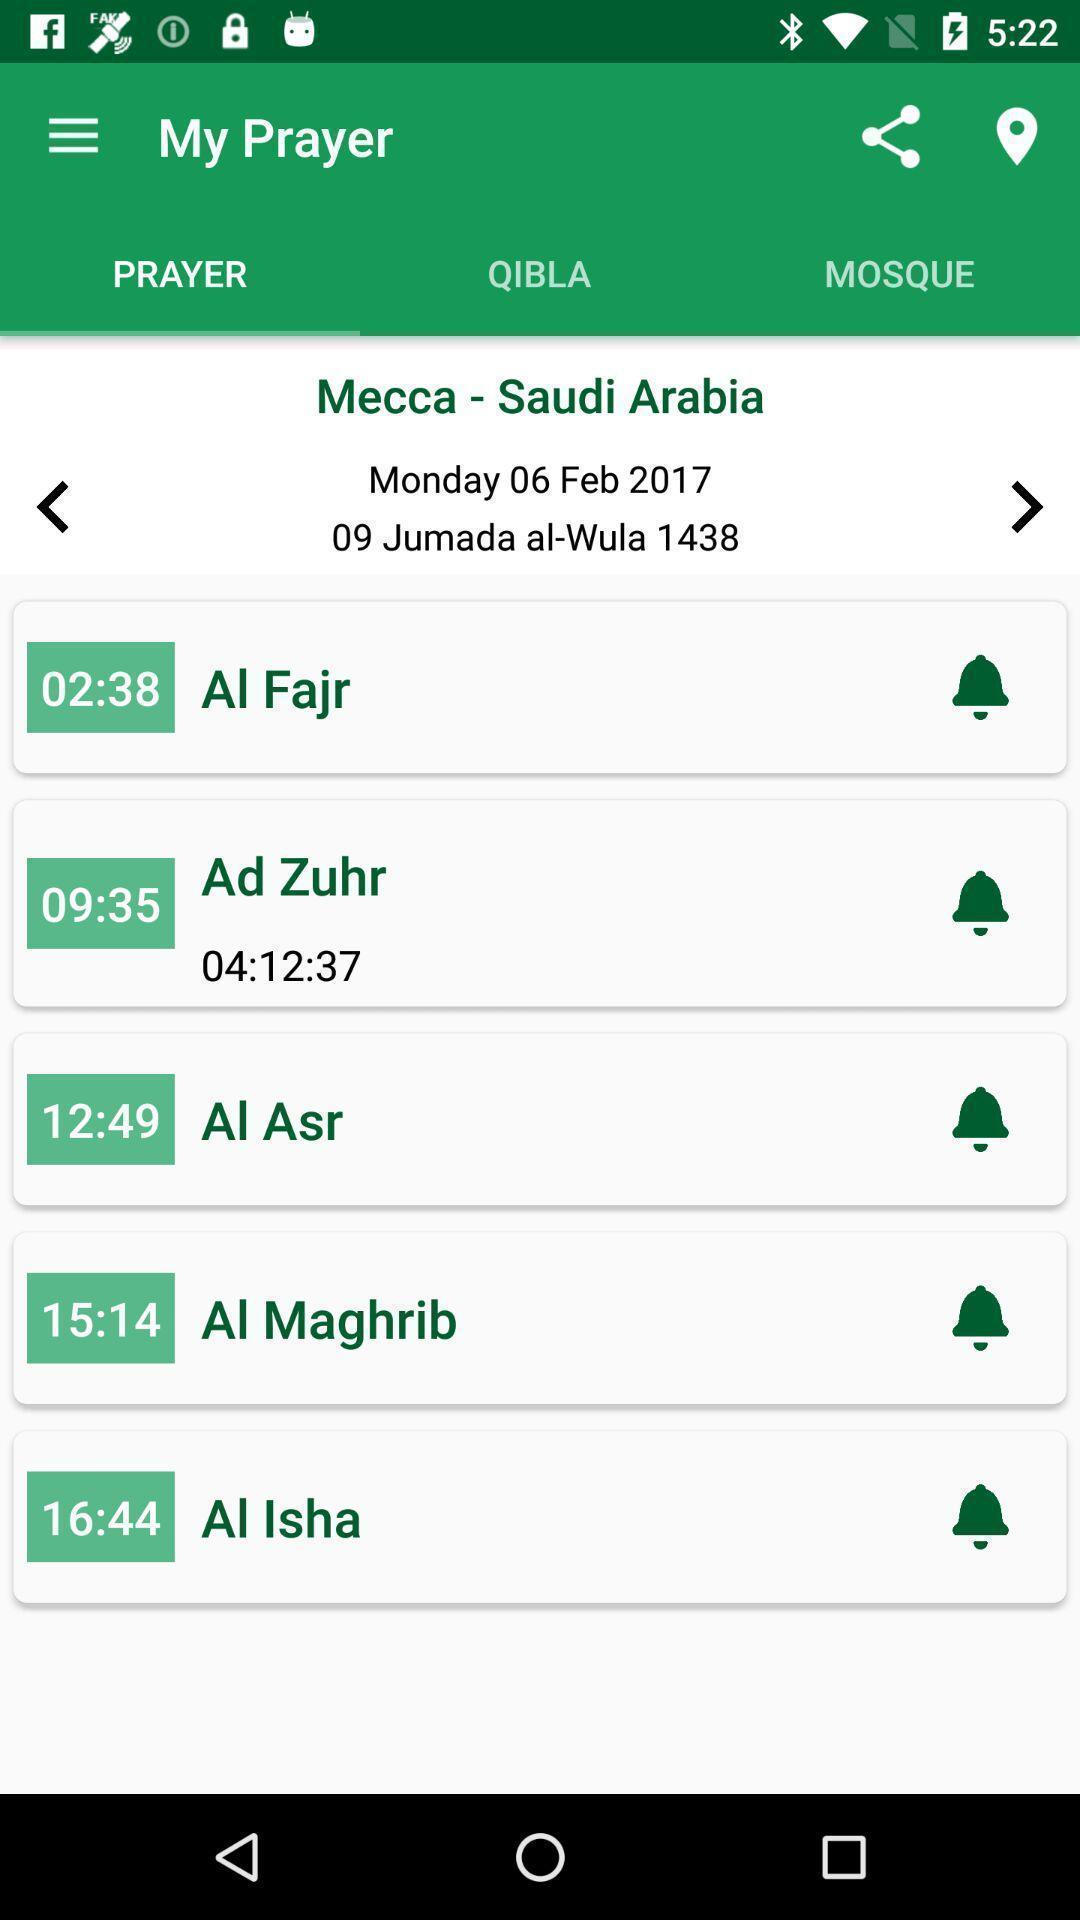Give me a summary of this screen capture. Page showing the options in prayer app. 